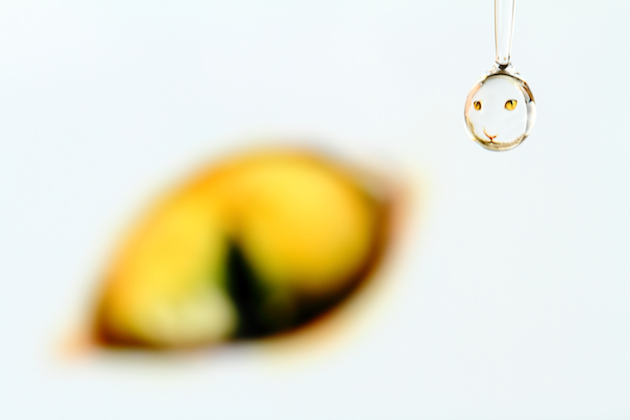What is the subject of this image? This image captures a single water droplet with a refraction of a smiley face inside it. It's a close-up shot with a blurred background that possibly contains a fruit-like object, which is not in focus. The photograph showcases skilled use of macro photography techniques to highlight the intricate details and the playful, creative aspect of capturing the smiley within a transient medium like water. 